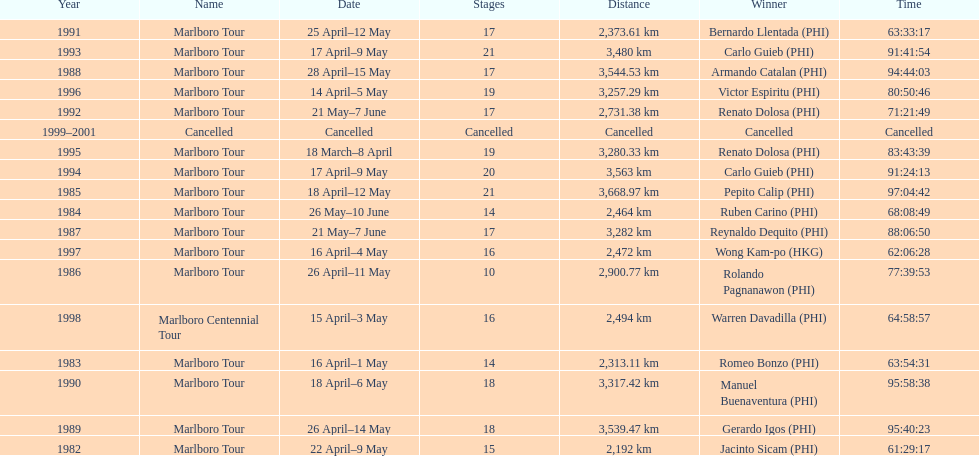How many stages was the 1982 marlboro tour? 15. 